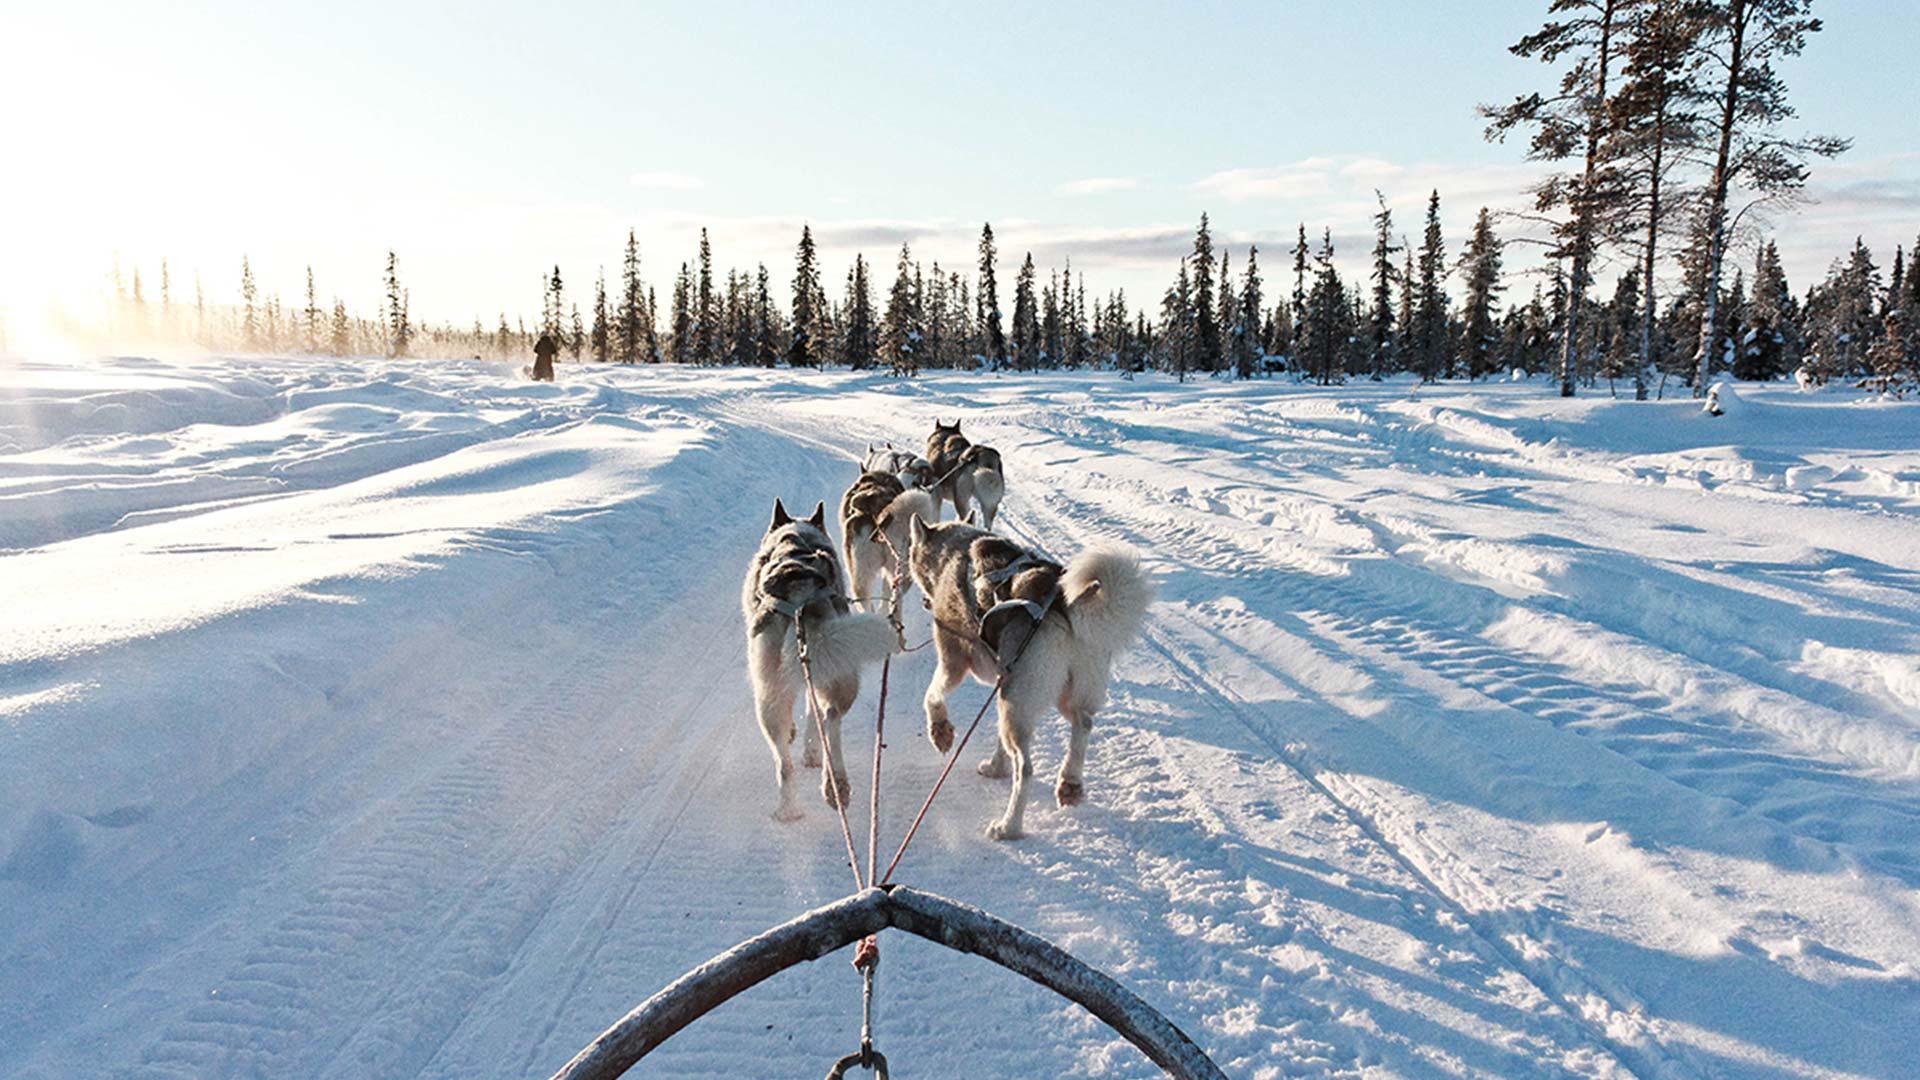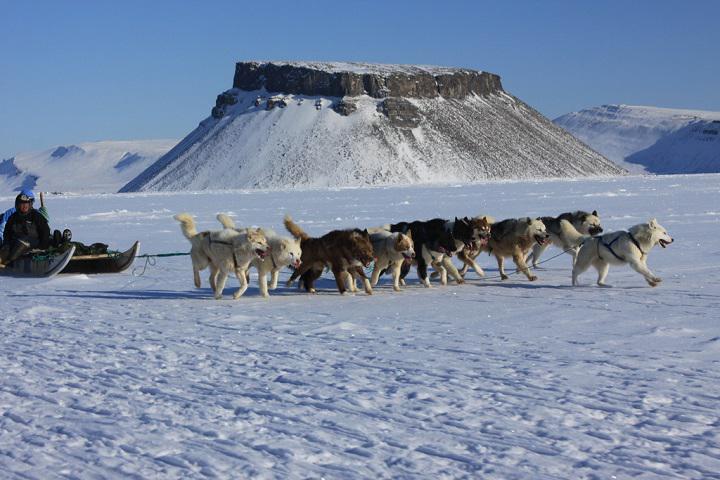The first image is the image on the left, the second image is the image on the right. Examine the images to the left and right. Is the description "An image shows a team of sled dogs headed toward the camera." accurate? Answer yes or no. No. The first image is the image on the left, the second image is the image on the right. For the images displayed, is the sentence "The sled dogs are resting in one of the images." factually correct? Answer yes or no. No. 